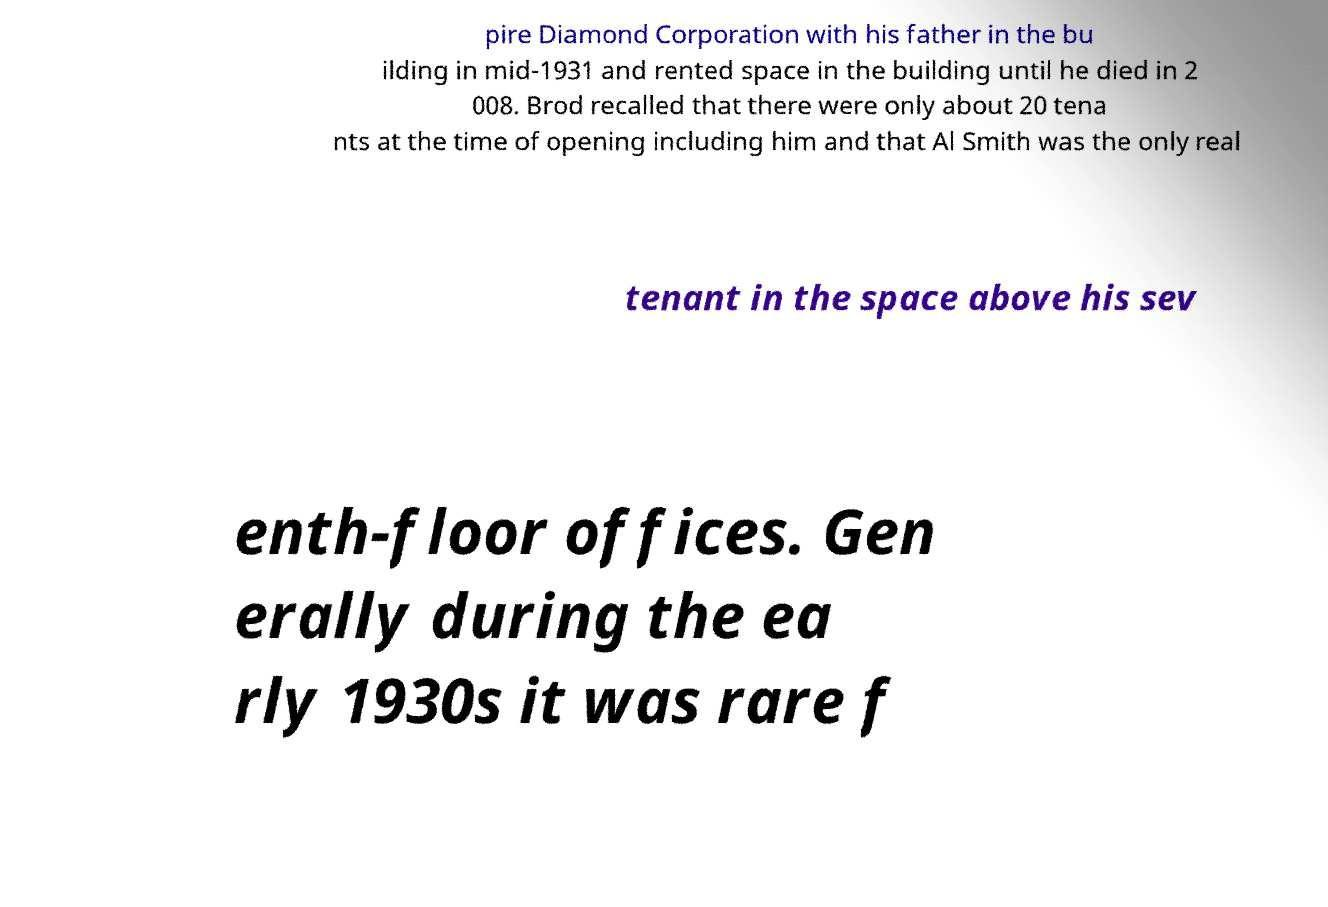Please identify and transcribe the text found in this image. pire Diamond Corporation with his father in the bu ilding in mid-1931 and rented space in the building until he died in 2 008. Brod recalled that there were only about 20 tena nts at the time of opening including him and that Al Smith was the only real tenant in the space above his sev enth-floor offices. Gen erally during the ea rly 1930s it was rare f 